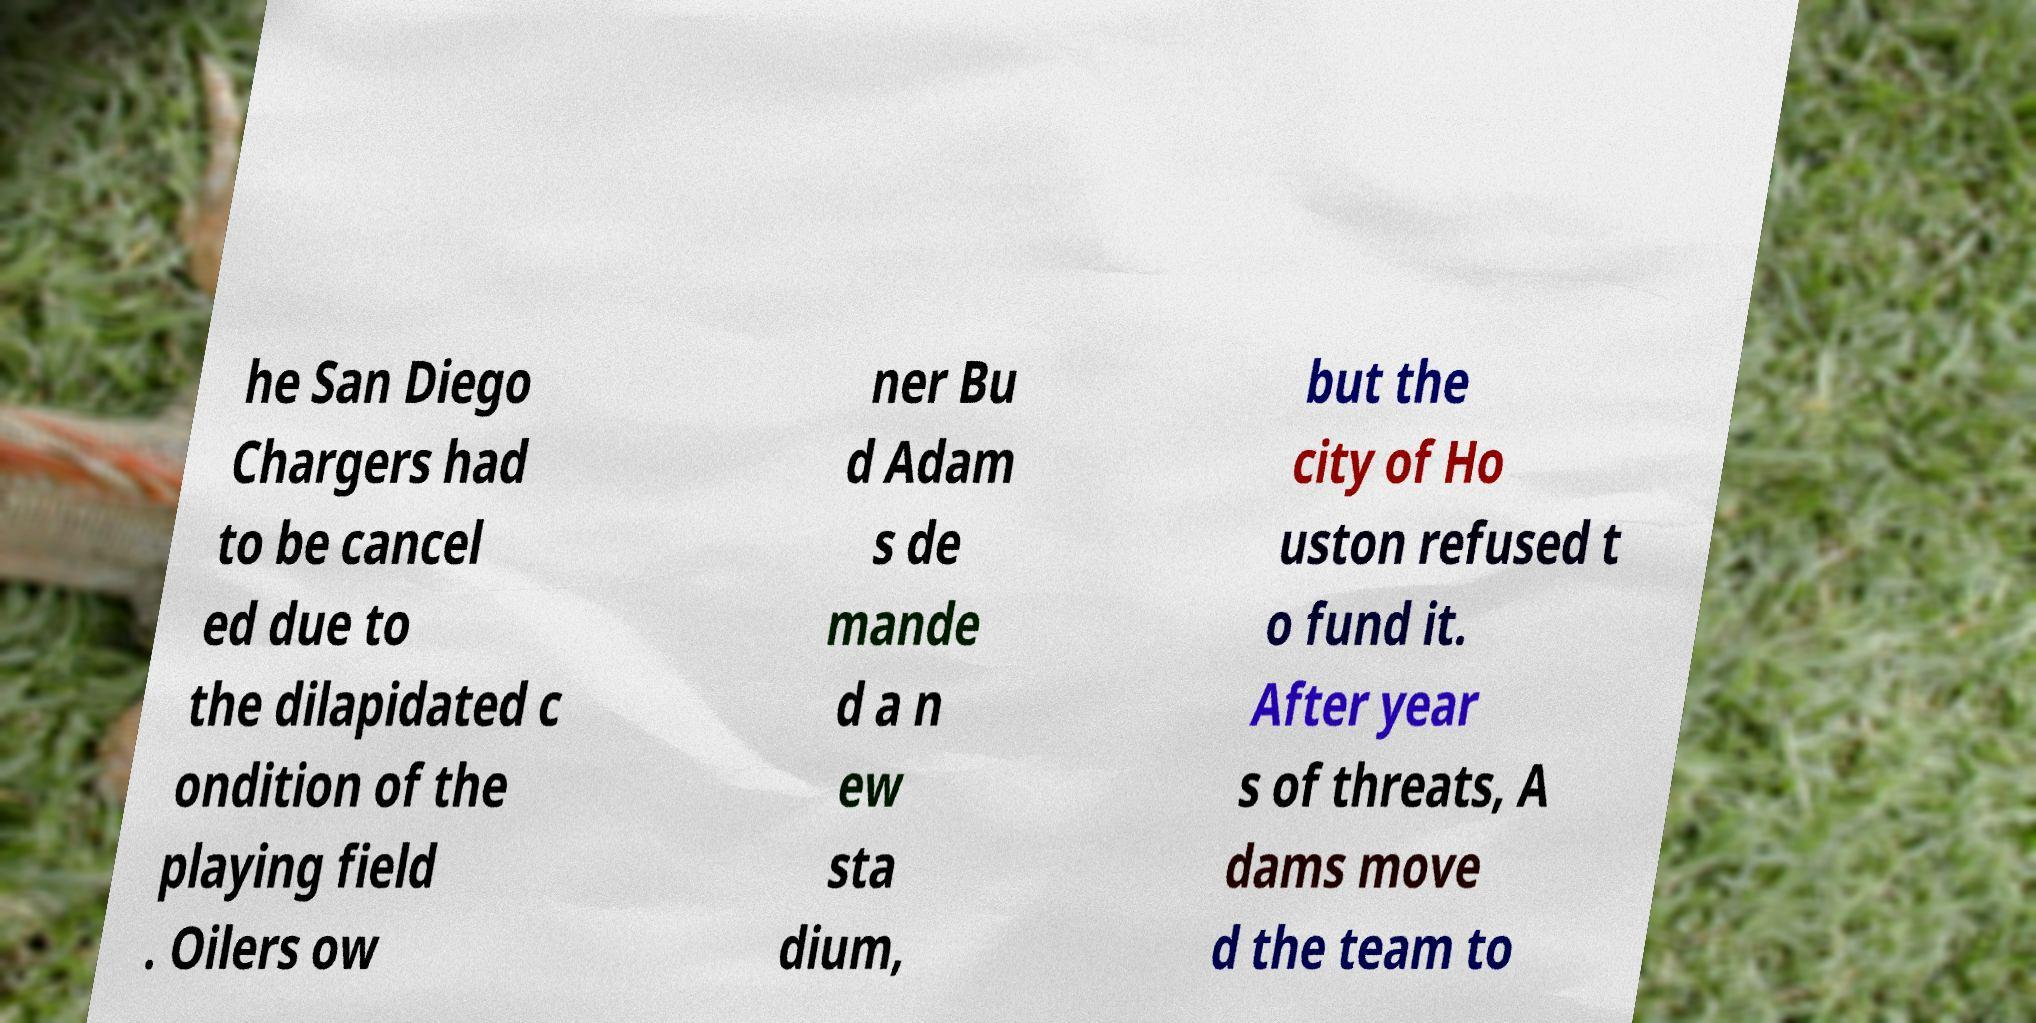There's text embedded in this image that I need extracted. Can you transcribe it verbatim? he San Diego Chargers had to be cancel ed due to the dilapidated c ondition of the playing field . Oilers ow ner Bu d Adam s de mande d a n ew sta dium, but the city of Ho uston refused t o fund it. After year s of threats, A dams move d the team to 